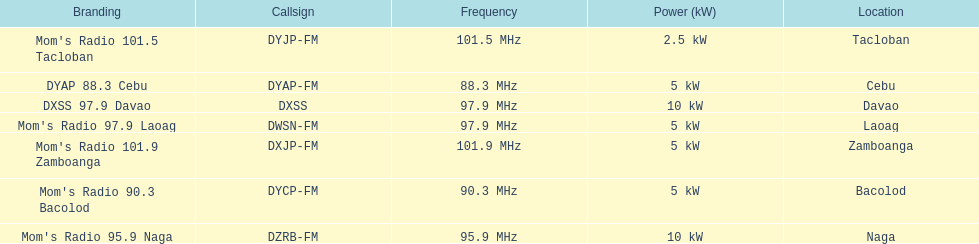How many stations broadcast with a power of 5kw? 4. 